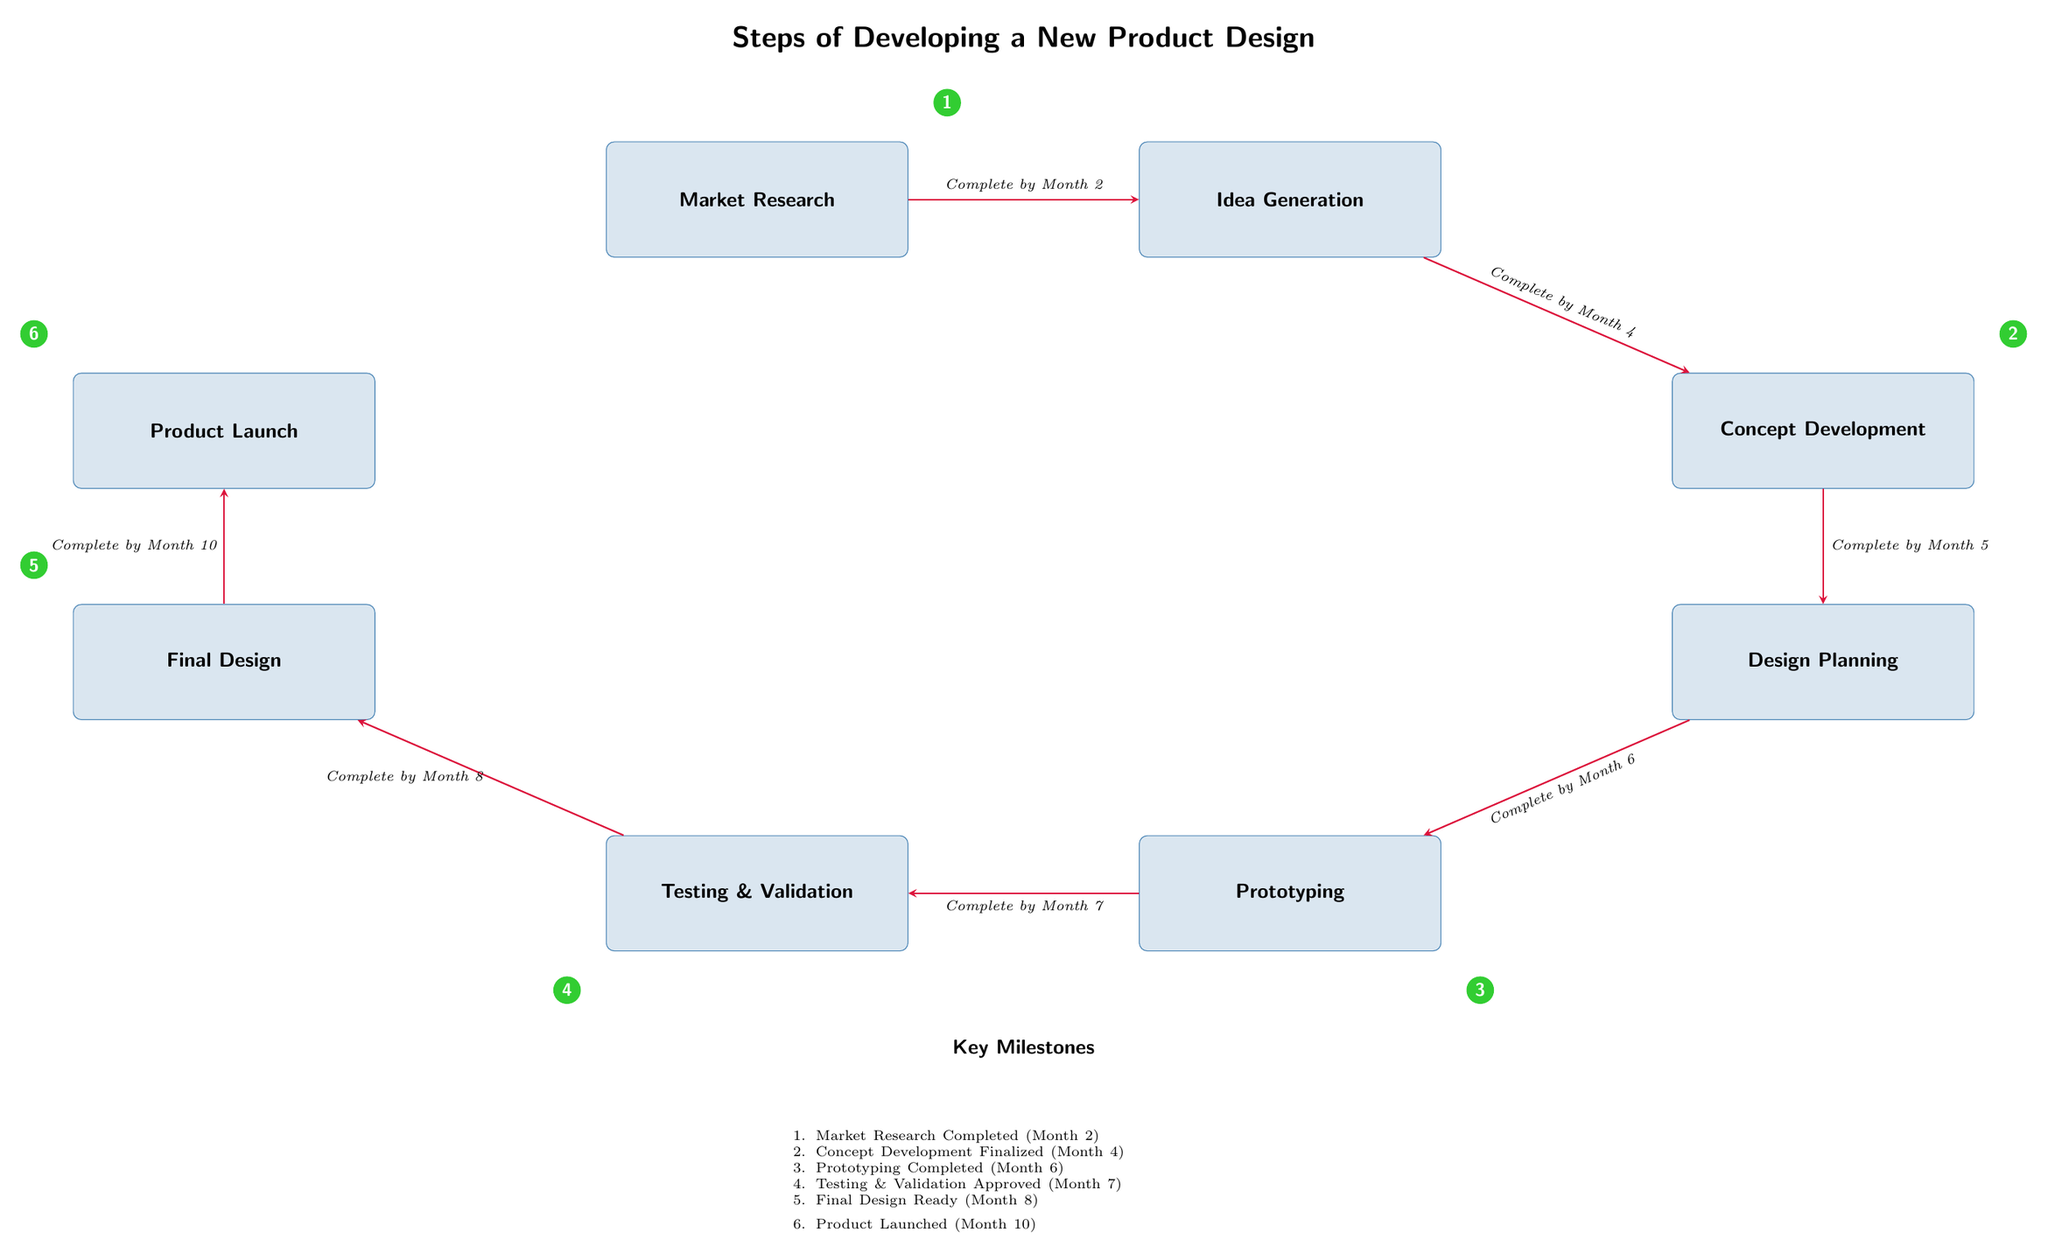What is the first step in the product design process? The diagram shows the first box labeled "Market Research," indicating the initial step in developing a new product design.
Answer: Market Research How many key milestones are listed in the diagram? The diagram contains six milestones marked with numbers 1 through 6, as indicated in the "Key Milestones" section.
Answer: 6 What is the completion month for Concept Development? The diagram notes the arrow from "Idea Generation" to "Concept Development," labeled with "Complete by Month 4," indicating when this step should be finalized.
Answer: Month 4 What step comes after Testing & Validation? In the diagram, the flow shows that after "Testing & Validation," the next step is "Final Design," which is directly connected to it by an arrow.
Answer: Final Design Which step is associated with milestone number 4? According to the diagram, milestone number 4 corresponds with "Testing & Validation," as it is labeled with the number 4 placed near that box.
Answer: Testing & Validation What milestone is reached after Prototyping? The diagram reveals that after "Prototyping," the next milestone reached is milestone number 4, associated with "Testing & Validation."
Answer: Milestone number 4 What action must be completed by Month 10? The flow of the diagram indicates that the last arrow leads to "Product Launch," which is labeled with "Complete by Month 10," denoting the deadline for this step.
Answer: Product Launch Which step is the last in the development timeline? The diagram positions "Product Launch" at the bottom of the flow, indicating it is the final step in the product design process.
Answer: Product Launch What is the relationship between Market Research and Idea Generation? The diagram shows an arrow leading from "Market Research" to "Idea Generation," signifying that these two steps are sequential in the product development process.
Answer: Sequential steps 